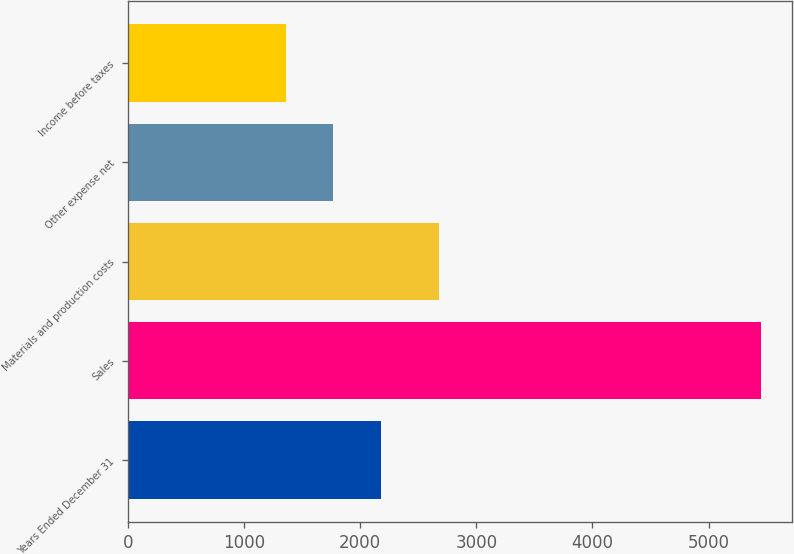Convert chart. <chart><loc_0><loc_0><loc_500><loc_500><bar_chart><fcel>Years Ended December 31<fcel>Sales<fcel>Materials and production costs<fcel>Other expense net<fcel>Income before taxes<nl><fcel>2178<fcel>5450<fcel>2682<fcel>1769<fcel>1360<nl></chart> 